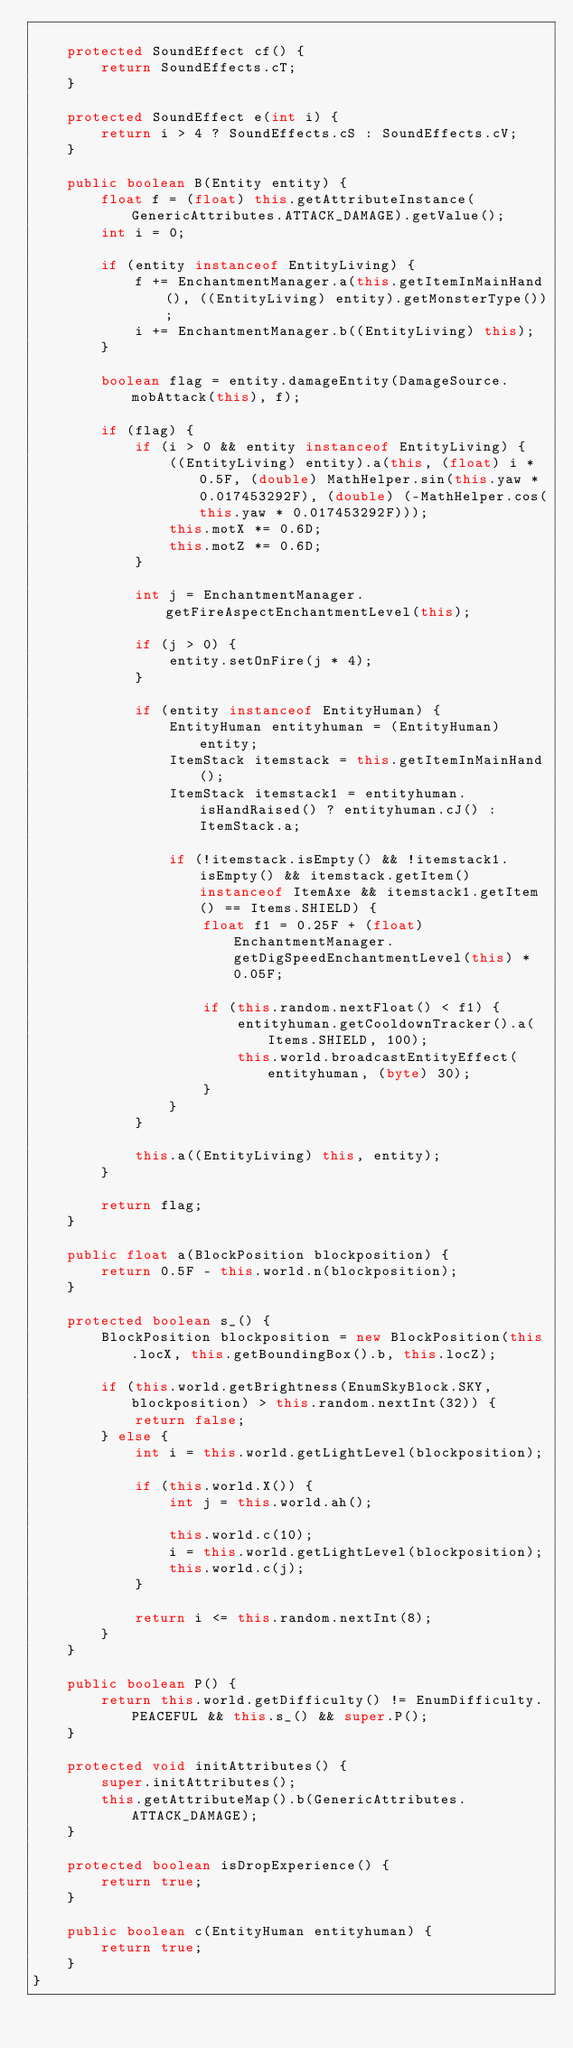Convert code to text. <code><loc_0><loc_0><loc_500><loc_500><_Java_>
    protected SoundEffect cf() {
        return SoundEffects.cT;
    }

    protected SoundEffect e(int i) {
        return i > 4 ? SoundEffects.cS : SoundEffects.cV;
    }

    public boolean B(Entity entity) {
        float f = (float) this.getAttributeInstance(GenericAttributes.ATTACK_DAMAGE).getValue();
        int i = 0;

        if (entity instanceof EntityLiving) {
            f += EnchantmentManager.a(this.getItemInMainHand(), ((EntityLiving) entity).getMonsterType());
            i += EnchantmentManager.b((EntityLiving) this);
        }

        boolean flag = entity.damageEntity(DamageSource.mobAttack(this), f);

        if (flag) {
            if (i > 0 && entity instanceof EntityLiving) {
                ((EntityLiving) entity).a(this, (float) i * 0.5F, (double) MathHelper.sin(this.yaw * 0.017453292F), (double) (-MathHelper.cos(this.yaw * 0.017453292F)));
                this.motX *= 0.6D;
                this.motZ *= 0.6D;
            }

            int j = EnchantmentManager.getFireAspectEnchantmentLevel(this);

            if (j > 0) {
                entity.setOnFire(j * 4);
            }

            if (entity instanceof EntityHuman) {
                EntityHuman entityhuman = (EntityHuman) entity;
                ItemStack itemstack = this.getItemInMainHand();
                ItemStack itemstack1 = entityhuman.isHandRaised() ? entityhuman.cJ() : ItemStack.a;

                if (!itemstack.isEmpty() && !itemstack1.isEmpty() && itemstack.getItem() instanceof ItemAxe && itemstack1.getItem() == Items.SHIELD) {
                    float f1 = 0.25F + (float) EnchantmentManager.getDigSpeedEnchantmentLevel(this) * 0.05F;

                    if (this.random.nextFloat() < f1) {
                        entityhuman.getCooldownTracker().a(Items.SHIELD, 100);
                        this.world.broadcastEntityEffect(entityhuman, (byte) 30);
                    }
                }
            }

            this.a((EntityLiving) this, entity);
        }

        return flag;
    }

    public float a(BlockPosition blockposition) {
        return 0.5F - this.world.n(blockposition);
    }

    protected boolean s_() {
        BlockPosition blockposition = new BlockPosition(this.locX, this.getBoundingBox().b, this.locZ);

        if (this.world.getBrightness(EnumSkyBlock.SKY, blockposition) > this.random.nextInt(32)) {
            return false;
        } else {
            int i = this.world.getLightLevel(blockposition);

            if (this.world.X()) {
                int j = this.world.ah();

                this.world.c(10);
                i = this.world.getLightLevel(blockposition);
                this.world.c(j);
            }

            return i <= this.random.nextInt(8);
        }
    }

    public boolean P() {
        return this.world.getDifficulty() != EnumDifficulty.PEACEFUL && this.s_() && super.P();
    }

    protected void initAttributes() {
        super.initAttributes();
        this.getAttributeMap().b(GenericAttributes.ATTACK_DAMAGE);
    }

    protected boolean isDropExperience() {
        return true;
    }

    public boolean c(EntityHuman entityhuman) {
        return true;
    }
}
</code> 